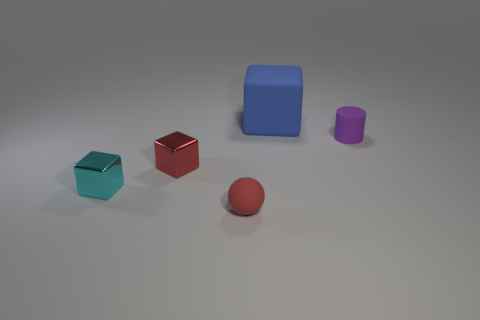There is a object that is on the right side of the small red shiny block and in front of the small rubber cylinder; what is its color?
Provide a short and direct response. Red. Are there any other matte cylinders that have the same color as the tiny matte cylinder?
Ensure brevity in your answer.  No. What is the color of the small object right of the matte cube?
Your answer should be very brief. Purple. There is a rubber cylinder that is to the right of the cyan metallic cube; are there any matte blocks that are in front of it?
Give a very brief answer. No. There is a cylinder; is it the same color as the tiny rubber thing that is in front of the purple cylinder?
Ensure brevity in your answer.  No. Are there any brown things made of the same material as the blue object?
Your response must be concise. No. How many small gray shiny objects are there?
Your response must be concise. 0. What is the material of the small cube in front of the small red object on the left side of the tiny red rubber object?
Your answer should be very brief. Metal. There is a large block that is the same material as the cylinder; what is its color?
Provide a short and direct response. Blue. There is a small thing that is the same color as the matte sphere; what is its shape?
Provide a succinct answer. Cube. 